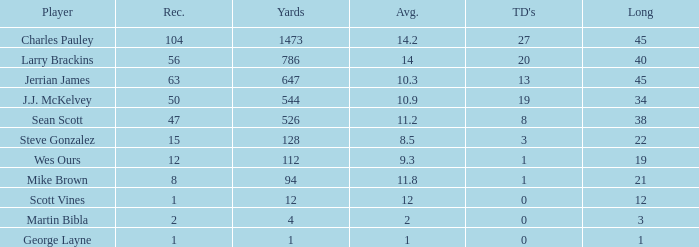What is the average for wes ours with over 1 reception and under 1 TD? None. 